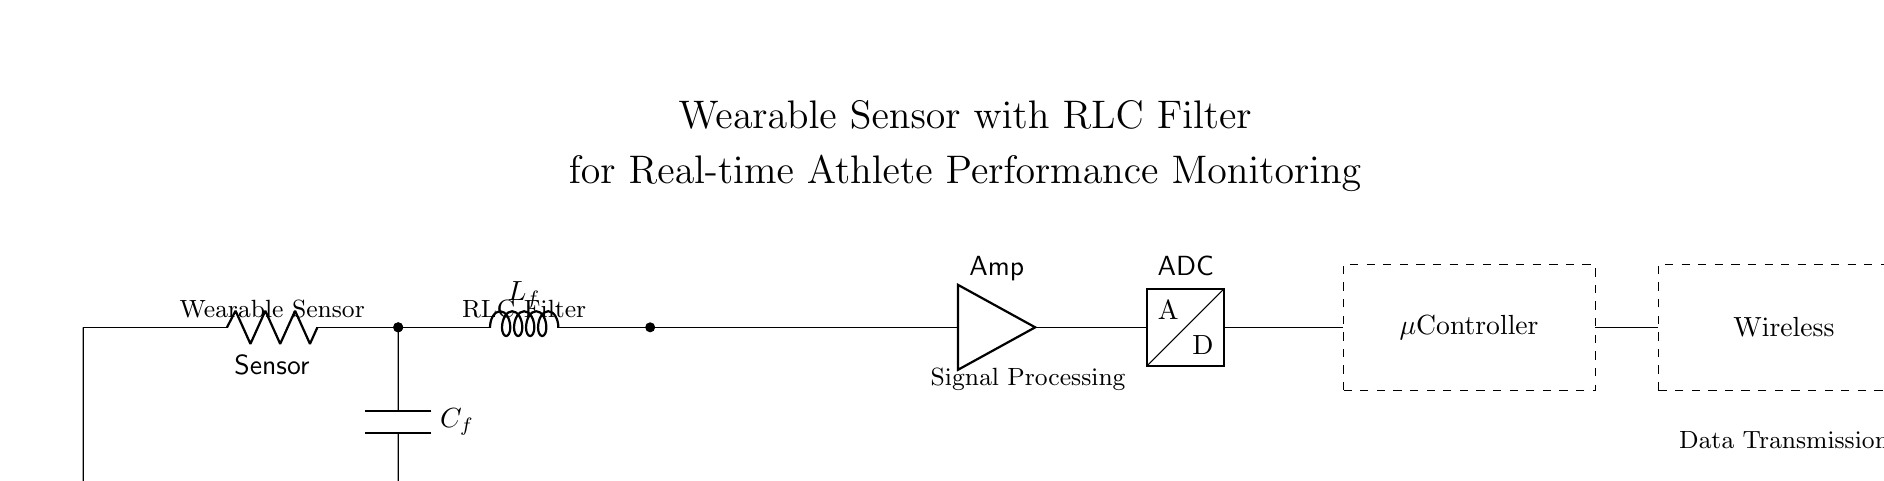What is the main function of the RLC filter in this circuit? The RLC filter is designed to filter specific frequencies from the signals received from the sensor, allowing for better signal processing and noise reduction for accurate performance monitoring.
Answer: Filtering frequencies What type of sensor is used in this wearable device? The diagram indicates that a sensor is present but does not specify its type. However, it is commonly a physiological sensor for monitoring athlete performance, such as heart rate or motion.
Answer: Physiological How many main components are in the circuit? The circuit consists of four main components: a sensor, resistor, inductor, and capacitor, followed by an amplifier, ADC, microcontroller, and wireless module, thus making a total of seven components in the main signal processing path.
Answer: Seven What role does the amplifier play in this circuit? The amplifier increases the signal strength from the RLC filter before it is passed to the ADC, ensuring that even weak signals from the sensor can be effectively processed and transmitted.
Answer: Signal amplification What is the primary purpose of the wireless module? The wireless module's purpose is to transmit the processed data from the microcontroller to external devices or networks for further analysis or monitoring, facilitating real-time performance tracking.
Answer: Data transmission How does the RLC filter affect signal quality? The RLC filter improves signal quality by attenuating unwanted noise and allowing specific frequency signals to pass through, resulting in clearer and more accurate data for performance analysis.
Answer: Improves clarity What device follows the ADC in the circuit? The microcontroller follows the ADC in the circuit. It is responsible for processing the digitized signals and executing required tasks, such as data analysis and control operations for the wearable sensor.
Answer: Microcontroller 